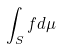<formula> <loc_0><loc_0><loc_500><loc_500>\int _ { S } f d \mu</formula> 